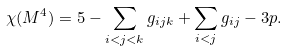<formula> <loc_0><loc_0><loc_500><loc_500>\chi ( M ^ { 4 } ) = 5 - \sum _ { i < j < k } g _ { i j k } + \sum _ { i < j } g _ { i j } - 3 p .</formula> 